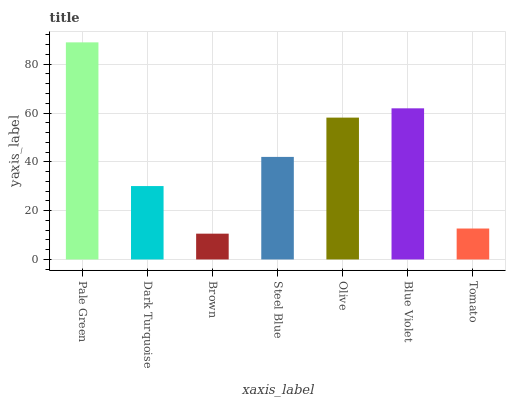Is Brown the minimum?
Answer yes or no. Yes. Is Pale Green the maximum?
Answer yes or no. Yes. Is Dark Turquoise the minimum?
Answer yes or no. No. Is Dark Turquoise the maximum?
Answer yes or no. No. Is Pale Green greater than Dark Turquoise?
Answer yes or no. Yes. Is Dark Turquoise less than Pale Green?
Answer yes or no. Yes. Is Dark Turquoise greater than Pale Green?
Answer yes or no. No. Is Pale Green less than Dark Turquoise?
Answer yes or no. No. Is Steel Blue the high median?
Answer yes or no. Yes. Is Steel Blue the low median?
Answer yes or no. Yes. Is Pale Green the high median?
Answer yes or no. No. Is Olive the low median?
Answer yes or no. No. 